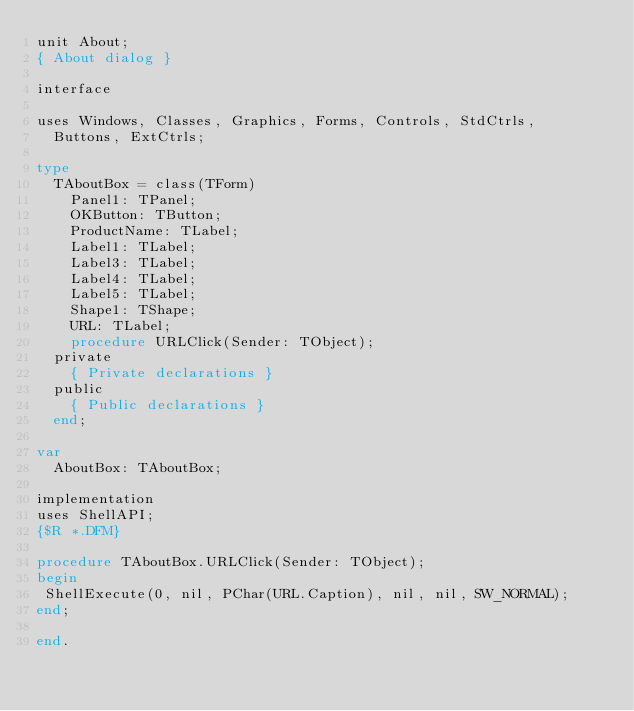Convert code to text. <code><loc_0><loc_0><loc_500><loc_500><_Pascal_>unit About;
{ About dialog }

interface

uses Windows, Classes, Graphics, Forms, Controls, StdCtrls,
  Buttons, ExtCtrls;

type
  TAboutBox = class(TForm)
    Panel1: TPanel;
    OKButton: TButton;
    ProductName: TLabel;
    Label1: TLabel;
    Label3: TLabel;
    Label4: TLabel;
    Label5: TLabel;
    Shape1: TShape;
    URL: TLabel;
    procedure URLClick(Sender: TObject);
  private
    { Private declarations }
  public
    { Public declarations }
  end;

var
  AboutBox: TAboutBox;

implementation
uses ShellAPI;
{$R *.DFM}

procedure TAboutBox.URLClick(Sender: TObject);
begin
 ShellExecute(0, nil, PChar(URL.Caption), nil, nil, SW_NORMAL);
end;

end.

</code> 